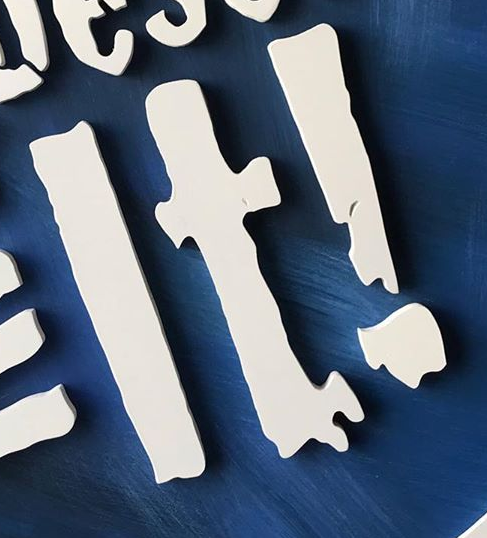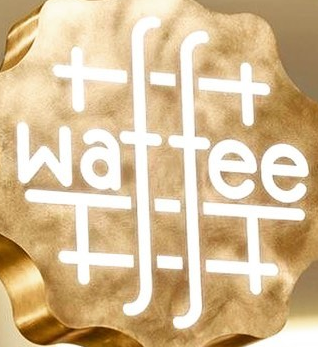Identify the words shown in these images in order, separated by a semicolon. It!; waffee 